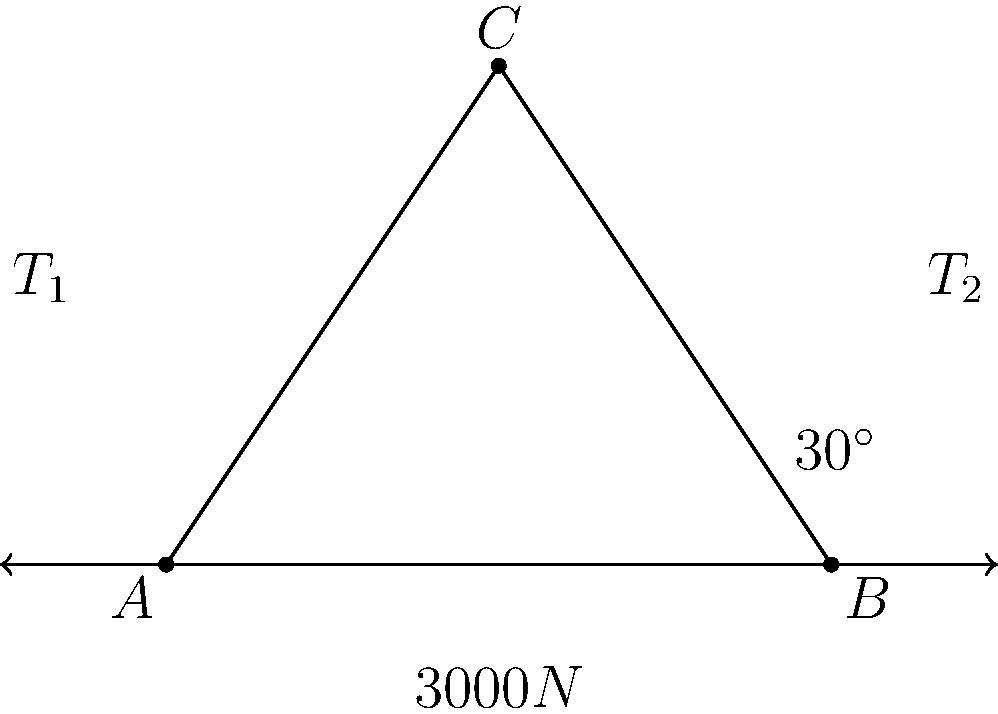In your art gallery, you're planning to install a large suspended ceiling piece. The installation weighs 3000N and is supported by two cables attached to the walls at points A and B, meeting at point C. The angle between cable T2 and the horizontal is 30°. Calculate the tension in cable T1 to ensure the structural integrity of the installation. Let's approach this step-by-step:

1) First, we need to understand that this is a problem of static equilibrium. The sum of all forces must equal zero.

2) We can break this into vertical and horizontal components:
   Vertical: $T_1\sin\theta_1 + T_2\sin30° = 3000N$
   Horizontal: $T_1\cos\theta_1 = T_2\cos30°$

3) We don't know $\theta_1$, but we can use the fact that $\tan\theta_1 = \frac{3}{2}$ (from the triangle's dimensions).

4) From the horizontal equation:
   $T_1 = \frac{T_2\cos30°}{\cos\theta_1}$

5) Substitute this into the vertical equation:
   $\frac{T_2\cos30°}{\cos\theta_1}\sin\theta_1 + T_2\sin30° = 3000$

6) Simplify using $\frac{\sin\theta_1}{\cos\theta_1} = \tan\theta_1 = \frac{3}{2}$:
   $T_2(\frac{3}{2}\cos30° + \sin30°) = 3000$

7) Solve for $T_2$:
   $T_2 = \frac{3000}{\frac{3}{2}\cos30° + \sin30°} \approx 2309.4N$

8) Now we can find $T_1$ using the horizontal equation:
   $T_1 = \frac{2309.4 \cos30°}{\cos\theta_1} = 2309.4 \cdot \frac{\cos30°}{\cos(\arctan(\frac{3}{2}))} \approx 2666.7N$

Therefore, the tension in cable T1 is approximately 2666.7N.
Answer: 2666.7N 